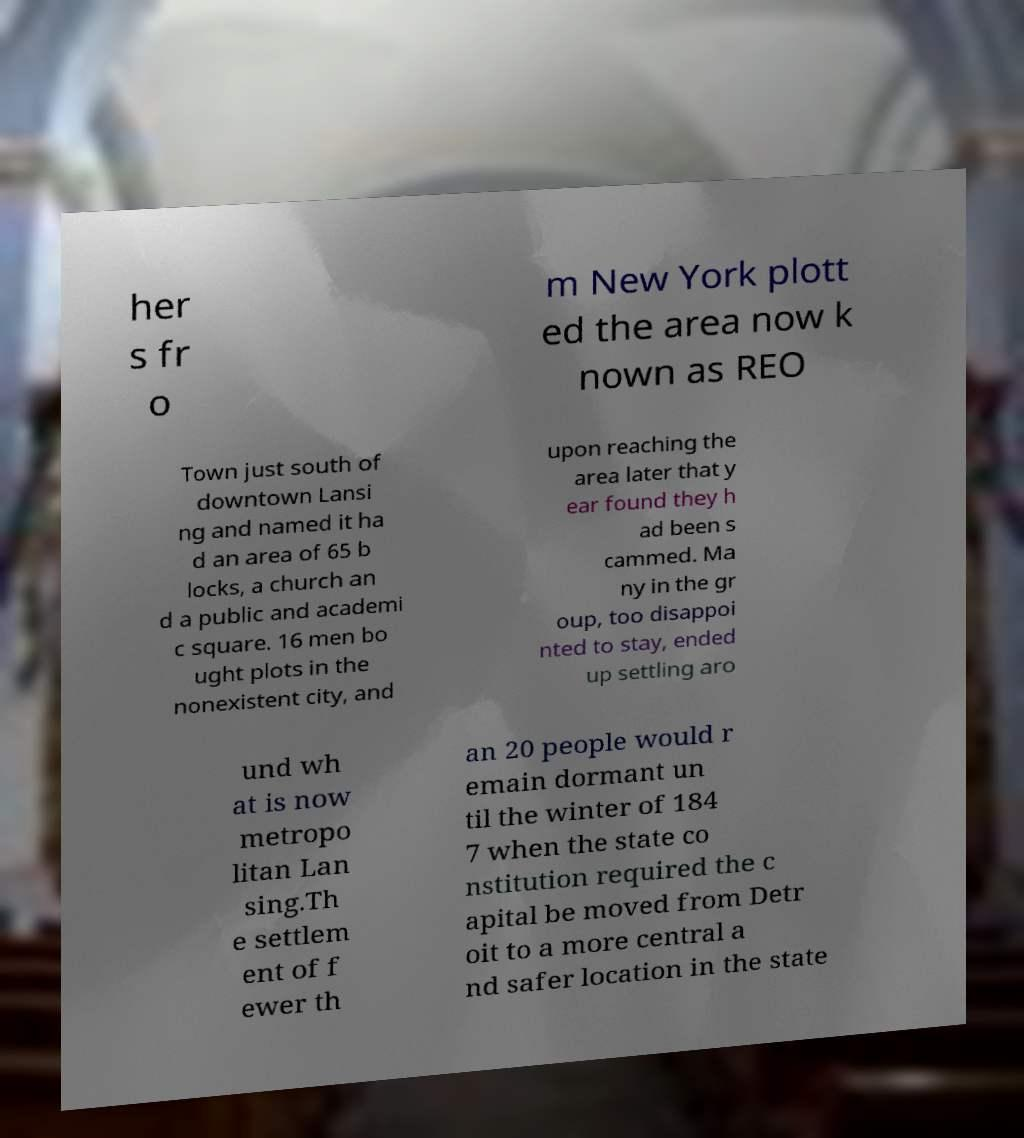There's text embedded in this image that I need extracted. Can you transcribe it verbatim? her s fr o m New York plott ed the area now k nown as REO Town just south of downtown Lansi ng and named it ha d an area of 65 b locks, a church an d a public and academi c square. 16 men bo ught plots in the nonexistent city, and upon reaching the area later that y ear found they h ad been s cammed. Ma ny in the gr oup, too disappoi nted to stay, ended up settling aro und wh at is now metropo litan Lan sing.Th e settlem ent of f ewer th an 20 people would r emain dormant un til the winter of 184 7 when the state co nstitution required the c apital be moved from Detr oit to a more central a nd safer location in the state 